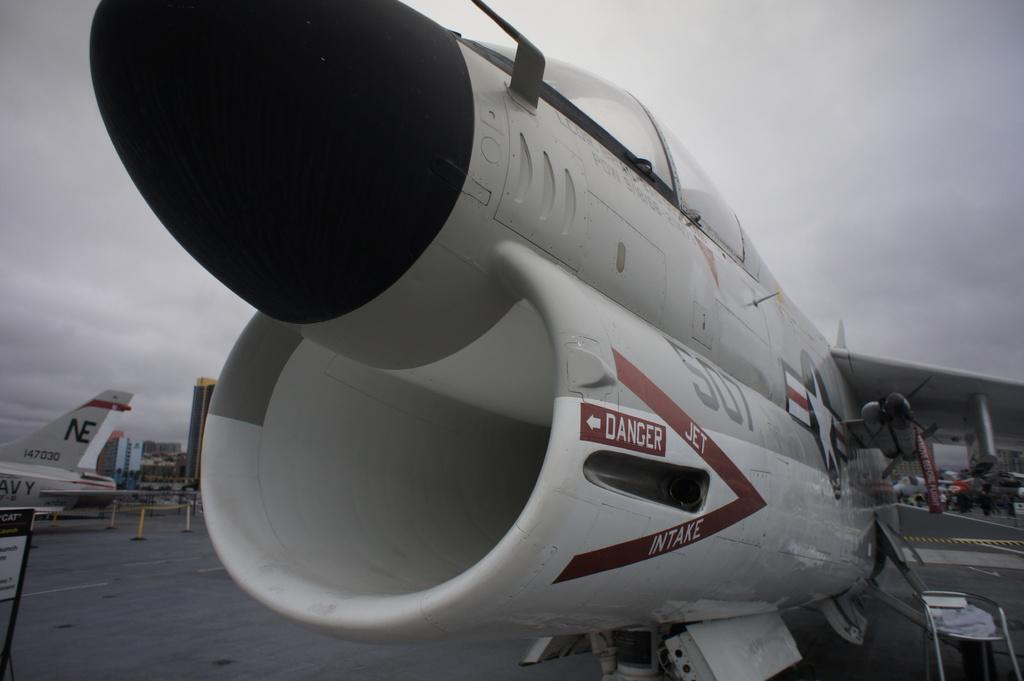<image>
Offer a succinct explanation of the picture presented. A military jet has a DANGER sign affixed to it with an arrow pointing to one of the plane's engines. 